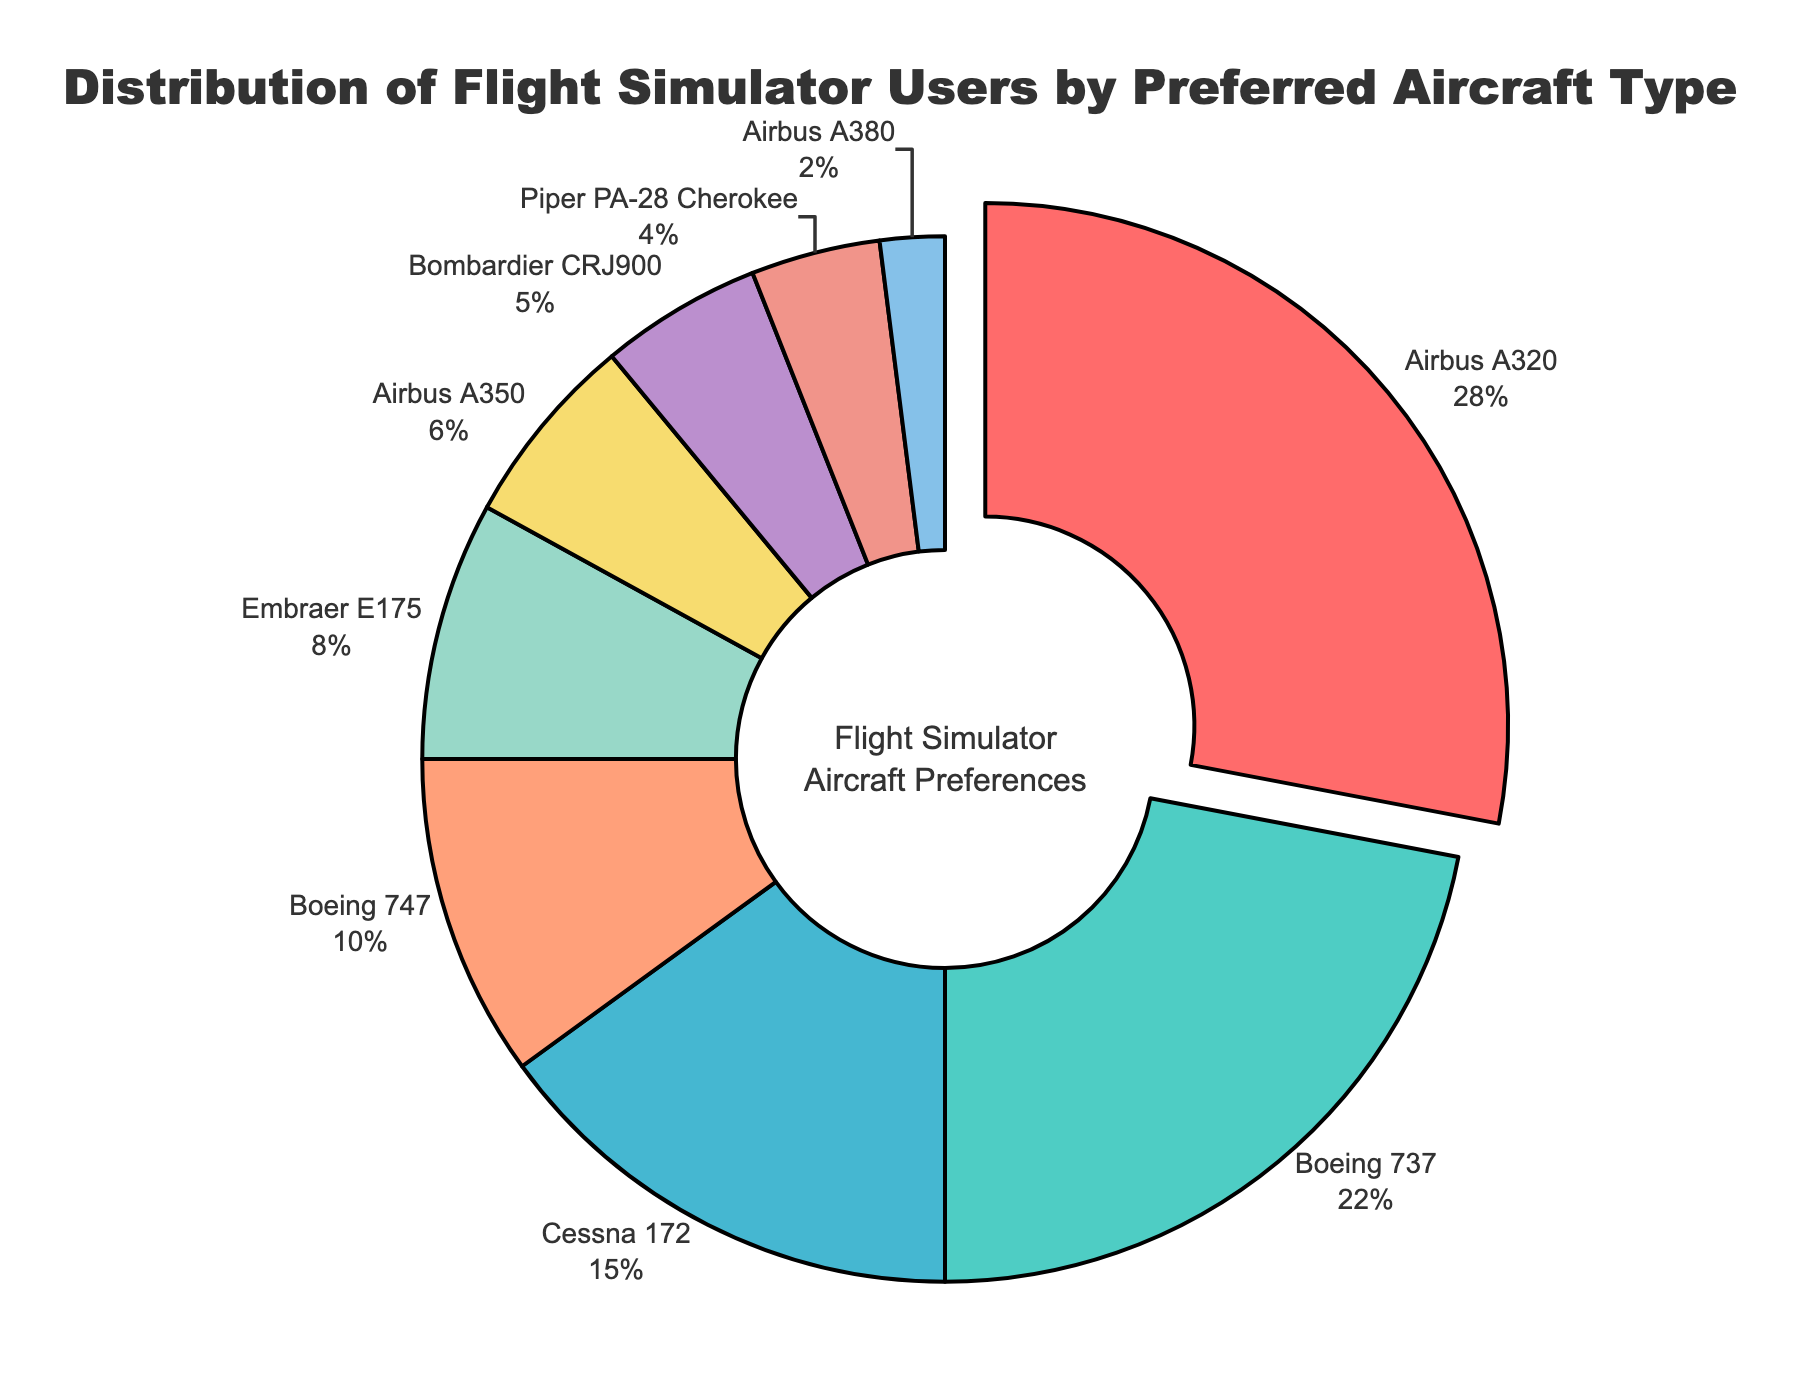What is the most preferred aircraft type among flight simulator users? The figure shows a pie chart with the distribution percentages. The aircraft type with the largest segment, or the one pulled out, is the most preferred.
Answer: Airbus A320 Which aircraft types collectively account for more than half of the user preferences? To determine this, add the percentages of the most popular choices until the total exceeds 50%. From the figure: Airbus A320 (28%) + Boeing 737 (22%) = 50%, and since this equals 50%, no further additions are needed.
Answer: Airbus A320 and Boeing 737 What is the difference in user preference between the Airbus A320 and the Cessna 172? Subtract the percentage of the Cessna 172 from the Airbus A320, based on their respective segments in the chart. Airbus A320 (28%) - Cessna 172 (15%) = 13%.
Answer: 13% Which aircraft type is less preferred than both the Cessna 172 and the Boeing 747? Compare the percentages on the chart for values smaller than both Cessna 172 (15%) and Boeing 747 (10%). The aircraft types less than 10% are Embraer E175 (8%), Airbus A350 (6%), Bombardier CRJ900 (5%), Piper PA-28 Cherokee (4%), and Airbus A380 (2%).
Answer: Embraer E175, Airbus A350, Bombardier CRJ900, Piper PA-28 Cherokee, Airbus A380 How many aircraft types have a preference percentage of 10% or less? Count the segments that are 10% or smaller by inspecting the pie chart. The relevant aircraft types are Boeing 747 (10%), Embraer E175 (8%), Airbus A350 (6%), Bombardier CRJ900 (5%), Piper PA-28 Cherokee (4%), and Airbus A380 (2%).
Answer: 6 